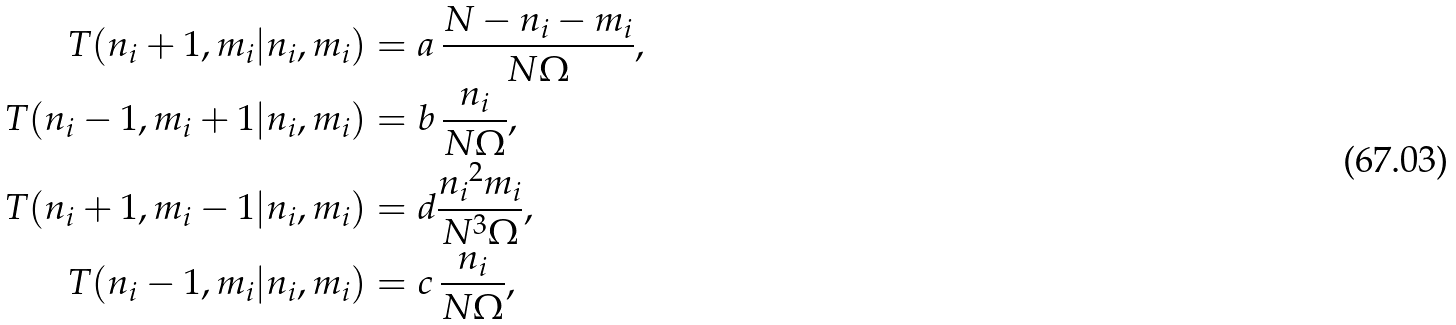<formula> <loc_0><loc_0><loc_500><loc_500>T ( n _ { i } + 1 , m _ { i } | n _ { i } , m _ { i } ) & = a \, \frac { N - n _ { i } - m _ { i } } { N \Omega } , \\ T ( n _ { i } - 1 , m _ { i } + 1 | n _ { i } , m _ { i } ) & = b \, \frac { n _ { i } } { N \Omega } , \\ T ( n _ { i } + 1 , m _ { i } - 1 | n _ { i } , m _ { i } ) & = d \frac { { n _ { i } } ^ { 2 } m _ { i } } { N ^ { 3 } \Omega } , \\ T ( n _ { i } - 1 , m _ { i } | n _ { i } , m _ { i } ) & = c \, \frac { n _ { i } } { N \Omega } ,</formula> 